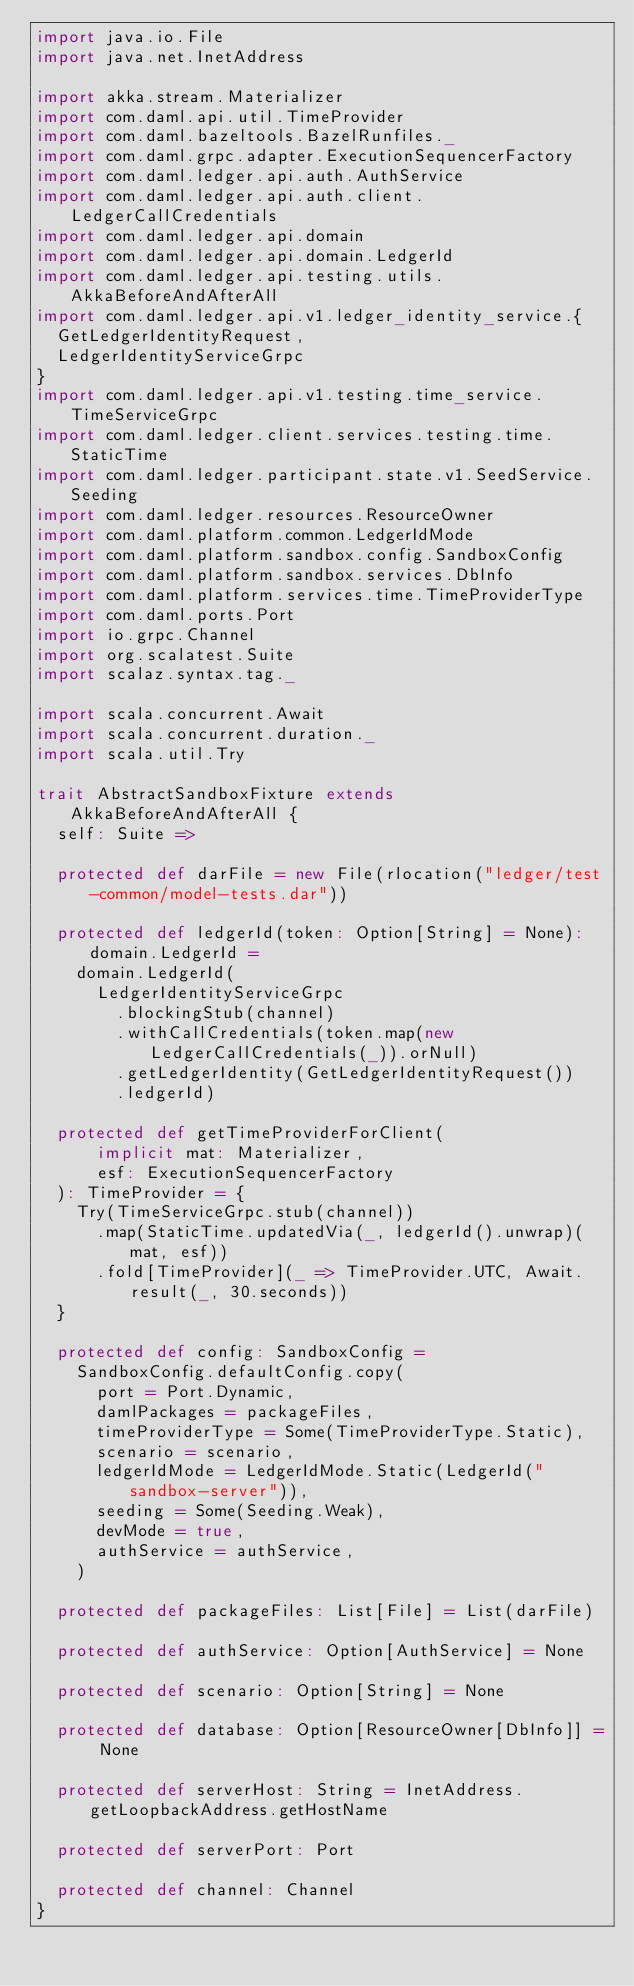Convert code to text. <code><loc_0><loc_0><loc_500><loc_500><_Scala_>import java.io.File
import java.net.InetAddress

import akka.stream.Materializer
import com.daml.api.util.TimeProvider
import com.daml.bazeltools.BazelRunfiles._
import com.daml.grpc.adapter.ExecutionSequencerFactory
import com.daml.ledger.api.auth.AuthService
import com.daml.ledger.api.auth.client.LedgerCallCredentials
import com.daml.ledger.api.domain
import com.daml.ledger.api.domain.LedgerId
import com.daml.ledger.api.testing.utils.AkkaBeforeAndAfterAll
import com.daml.ledger.api.v1.ledger_identity_service.{
  GetLedgerIdentityRequest,
  LedgerIdentityServiceGrpc
}
import com.daml.ledger.api.v1.testing.time_service.TimeServiceGrpc
import com.daml.ledger.client.services.testing.time.StaticTime
import com.daml.ledger.participant.state.v1.SeedService.Seeding
import com.daml.ledger.resources.ResourceOwner
import com.daml.platform.common.LedgerIdMode
import com.daml.platform.sandbox.config.SandboxConfig
import com.daml.platform.sandbox.services.DbInfo
import com.daml.platform.services.time.TimeProviderType
import com.daml.ports.Port
import io.grpc.Channel
import org.scalatest.Suite
import scalaz.syntax.tag._

import scala.concurrent.Await
import scala.concurrent.duration._
import scala.util.Try

trait AbstractSandboxFixture extends AkkaBeforeAndAfterAll {
  self: Suite =>

  protected def darFile = new File(rlocation("ledger/test-common/model-tests.dar"))

  protected def ledgerId(token: Option[String] = None): domain.LedgerId =
    domain.LedgerId(
      LedgerIdentityServiceGrpc
        .blockingStub(channel)
        .withCallCredentials(token.map(new LedgerCallCredentials(_)).orNull)
        .getLedgerIdentity(GetLedgerIdentityRequest())
        .ledgerId)

  protected def getTimeProviderForClient(
      implicit mat: Materializer,
      esf: ExecutionSequencerFactory
  ): TimeProvider = {
    Try(TimeServiceGrpc.stub(channel))
      .map(StaticTime.updatedVia(_, ledgerId().unwrap)(mat, esf))
      .fold[TimeProvider](_ => TimeProvider.UTC, Await.result(_, 30.seconds))
  }

  protected def config: SandboxConfig =
    SandboxConfig.defaultConfig.copy(
      port = Port.Dynamic,
      damlPackages = packageFiles,
      timeProviderType = Some(TimeProviderType.Static),
      scenario = scenario,
      ledgerIdMode = LedgerIdMode.Static(LedgerId("sandbox-server")),
      seeding = Some(Seeding.Weak),
      devMode = true,
      authService = authService,
    )

  protected def packageFiles: List[File] = List(darFile)

  protected def authService: Option[AuthService] = None

  protected def scenario: Option[String] = None

  protected def database: Option[ResourceOwner[DbInfo]] = None

  protected def serverHost: String = InetAddress.getLoopbackAddress.getHostName

  protected def serverPort: Port

  protected def channel: Channel
}
</code> 